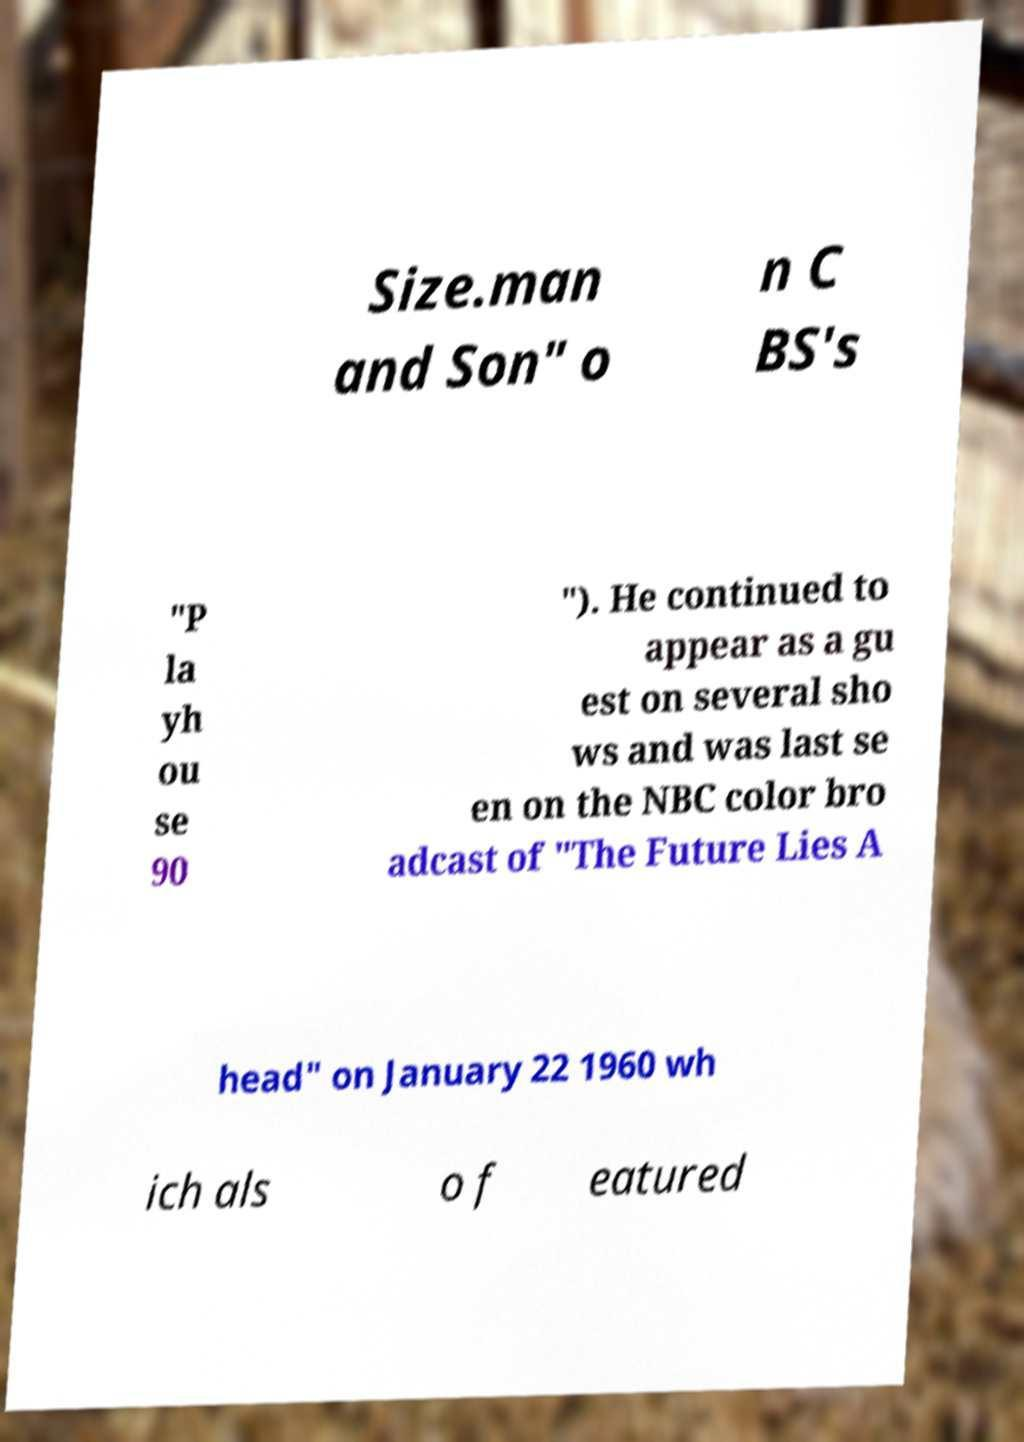What messages or text are displayed in this image? I need them in a readable, typed format. Size.man and Son" o n C BS's "P la yh ou se 90 "). He continued to appear as a gu est on several sho ws and was last se en on the NBC color bro adcast of "The Future Lies A head" on January 22 1960 wh ich als o f eatured 